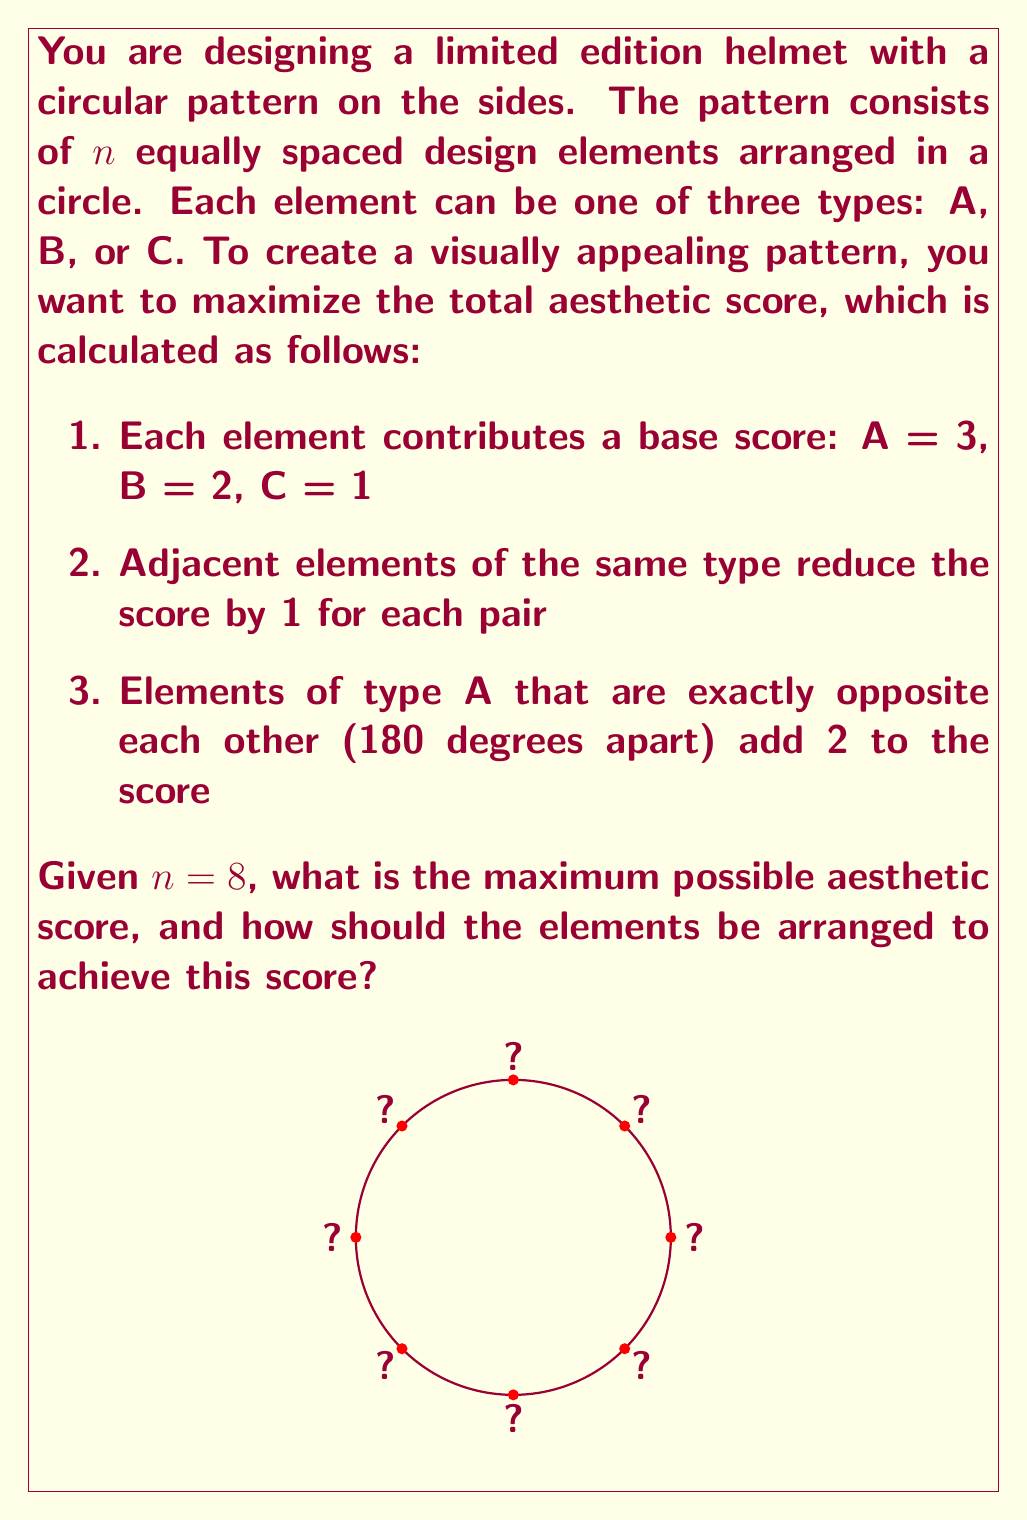Could you help me with this problem? To solve this optimization problem, we need to consider the trade-offs between maximizing the number of high-scoring elements (A) and avoiding adjacent pairs of the same type. Here's a step-by-step approach:

1. First, let's consider the maximum number of A elements we can use without having them adjacent:
   - We can place 4 A elements at alternating positions (0°, 90°, 180°, 270°)
   - This arrangement also maximizes the bonus for opposite A elements (2 pairs)

2. The remaining 4 positions can be filled with B and C elements:
   - To avoid adjacent pairs, we should alternate B and C

3. Let's calculate the score for this arrangement (A-B-A-C-A-B-A-C):
   - Base score: (4 × 3) + (2 × 2) + (2 × 1) = 12 + 4 + 2 = 18
   - Bonus for opposite A elements: 2 × 2 = 4
   - Total score: 18 + 4 = 22

4. We can verify that this is indeed the maximum score:
   - Adding more A elements would create adjacent pairs, reducing the score
   - Replacing B with C would lower the base score
   - Any other arrangement of A elements would reduce the opposite pair bonus

5. The optimal arrangement can be represented as:

   [asy]
   unitsize(40);
   draw(circle((0,0),1));
   string[] labels = {"A","B","A","C","A","B","A","C"};
   for(int i=0; i<8; ++i) {
     dot(dir(45*i));
     label(labels[i], dir(45*i), dir(45*i));
   }
   [/asy]

This arrangement maximizes the use of high-scoring A elements while avoiding adjacent pairs and maximizing the bonus for opposite A elements.
Answer: The maximum possible aesthetic score is 22, achieved by arranging the elements in the pattern A-B-A-C-A-B-A-C. 